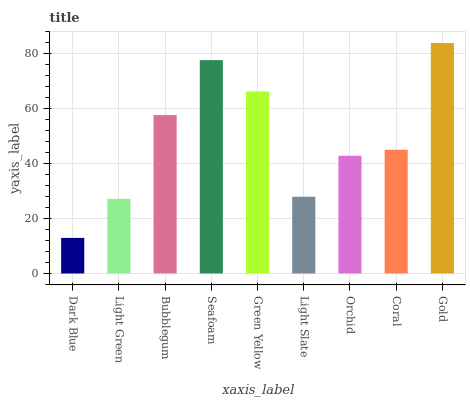Is Dark Blue the minimum?
Answer yes or no. Yes. Is Gold the maximum?
Answer yes or no. Yes. Is Light Green the minimum?
Answer yes or no. No. Is Light Green the maximum?
Answer yes or no. No. Is Light Green greater than Dark Blue?
Answer yes or no. Yes. Is Dark Blue less than Light Green?
Answer yes or no. Yes. Is Dark Blue greater than Light Green?
Answer yes or no. No. Is Light Green less than Dark Blue?
Answer yes or no. No. Is Coral the high median?
Answer yes or no. Yes. Is Coral the low median?
Answer yes or no. Yes. Is Orchid the high median?
Answer yes or no. No. Is Green Yellow the low median?
Answer yes or no. No. 